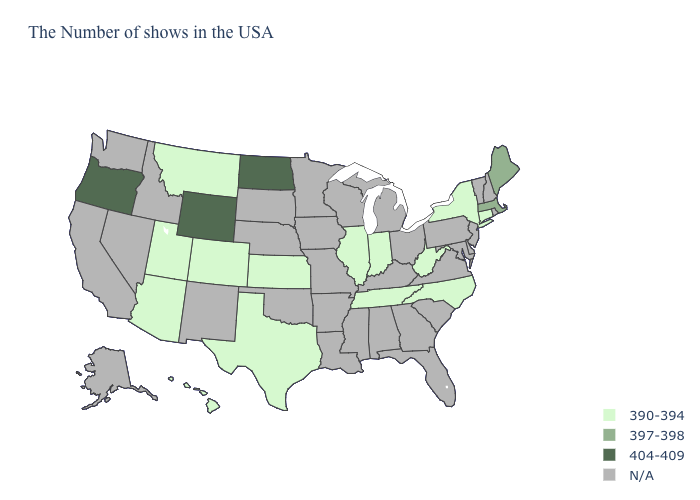Name the states that have a value in the range 404-409?
Keep it brief. North Dakota, Wyoming, Oregon. Name the states that have a value in the range 397-398?
Write a very short answer. Maine, Massachusetts. Name the states that have a value in the range N/A?
Write a very short answer. Rhode Island, New Hampshire, Vermont, New Jersey, Delaware, Maryland, Pennsylvania, Virginia, South Carolina, Ohio, Florida, Georgia, Michigan, Kentucky, Alabama, Wisconsin, Mississippi, Louisiana, Missouri, Arkansas, Minnesota, Iowa, Nebraska, Oklahoma, South Dakota, New Mexico, Idaho, Nevada, California, Washington, Alaska. Name the states that have a value in the range 397-398?
Answer briefly. Maine, Massachusetts. What is the value of Arizona?
Answer briefly. 390-394. Among the states that border Nevada , which have the lowest value?
Short answer required. Utah, Arizona. What is the value of Arizona?
Short answer required. 390-394. Name the states that have a value in the range 397-398?
Be succinct. Maine, Massachusetts. Name the states that have a value in the range 390-394?
Be succinct. Connecticut, New York, North Carolina, West Virginia, Indiana, Tennessee, Illinois, Kansas, Texas, Colorado, Utah, Montana, Arizona, Hawaii. Which states hav the highest value in the MidWest?
Write a very short answer. North Dakota. What is the value of Massachusetts?
Keep it brief. 397-398. Does Massachusetts have the lowest value in the Northeast?
Give a very brief answer. No. What is the value of Mississippi?
Be succinct. N/A. Does North Dakota have the highest value in the USA?
Write a very short answer. Yes. Does Colorado have the lowest value in the USA?
Short answer required. Yes. 